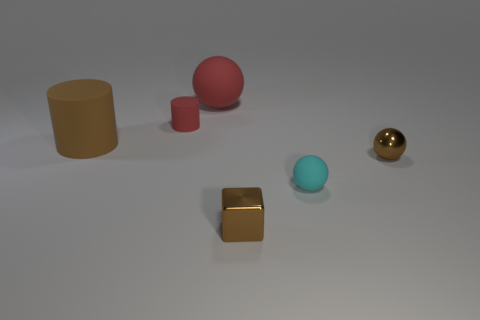Subtract all red matte spheres. How many spheres are left? 2 Add 1 small gray spheres. How many objects exist? 7 Subtract all brown cylinders. How many cylinders are left? 1 Add 1 large purple metallic spheres. How many large purple metallic spheres exist? 1 Subtract 1 cyan balls. How many objects are left? 5 Subtract all cubes. How many objects are left? 5 Subtract 2 balls. How many balls are left? 1 Subtract all green balls. Subtract all green cubes. How many balls are left? 3 Subtract all tiny blue rubber spheres. Subtract all big brown cylinders. How many objects are left? 5 Add 4 shiny things. How many shiny things are left? 6 